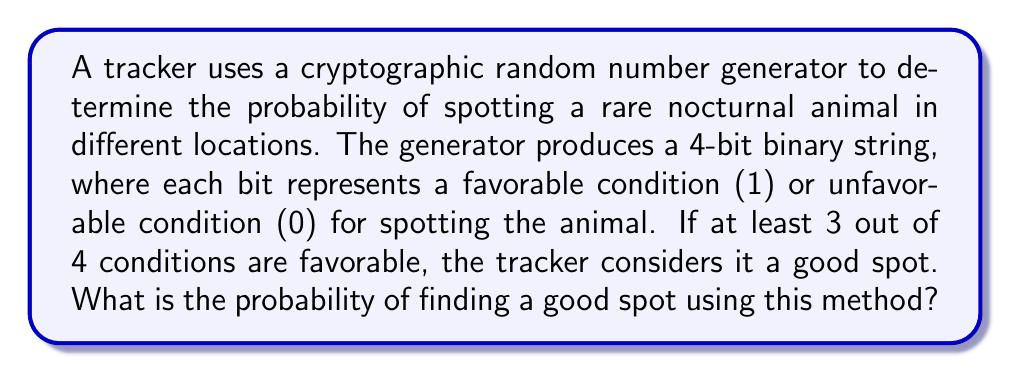Solve this math problem. Let's approach this step-by-step:

1) First, we need to understand what constitutes a "good spot". It's when at least 3 out of 4 bits are 1's.

2) The possible 4-bit strings that meet this criteria are:
   1111, 1110, 1101, 1011, 0111

3) Now, let's calculate the probability. In a 4-bit string, there are $2^4 = 16$ possible outcomes in total.

4) The probability is the number of favorable outcomes divided by the total number of possible outcomes:

   $$P(\text{good spot}) = \frac{\text{number of favorable outcomes}}{\text{total number of outcomes}}$$

5) We have 5 favorable outcomes (the strings listed in step 2) out of 16 total outcomes.

6) Therefore, the probability is:

   $$P(\text{good spot}) = \frac{5}{16} = 0.3125$$

7) This can also be expressed as a percentage: $0.3125 \times 100\% = 31.25\%$

The cryptographic nature of the random number generator ensures that each bit is truly random and independent, making this probability calculation valid.
Answer: $\frac{5}{16}$ or $0.3125$ or $31.25\%$ 